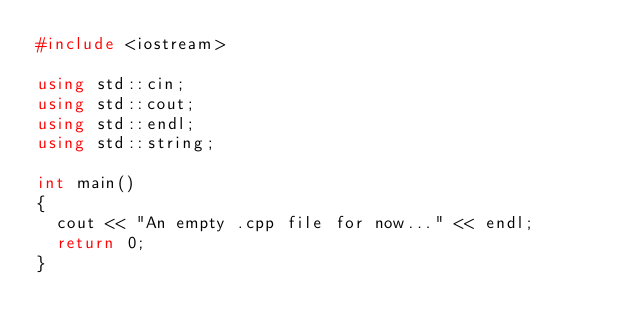Convert code to text. <code><loc_0><loc_0><loc_500><loc_500><_C++_>#include <iostream>

using std::cin;
using std::cout;
using std::endl;
using std::string;

int main()
{
	cout << "An empty .cpp file for now..." << endl;
	return 0;
}</code> 